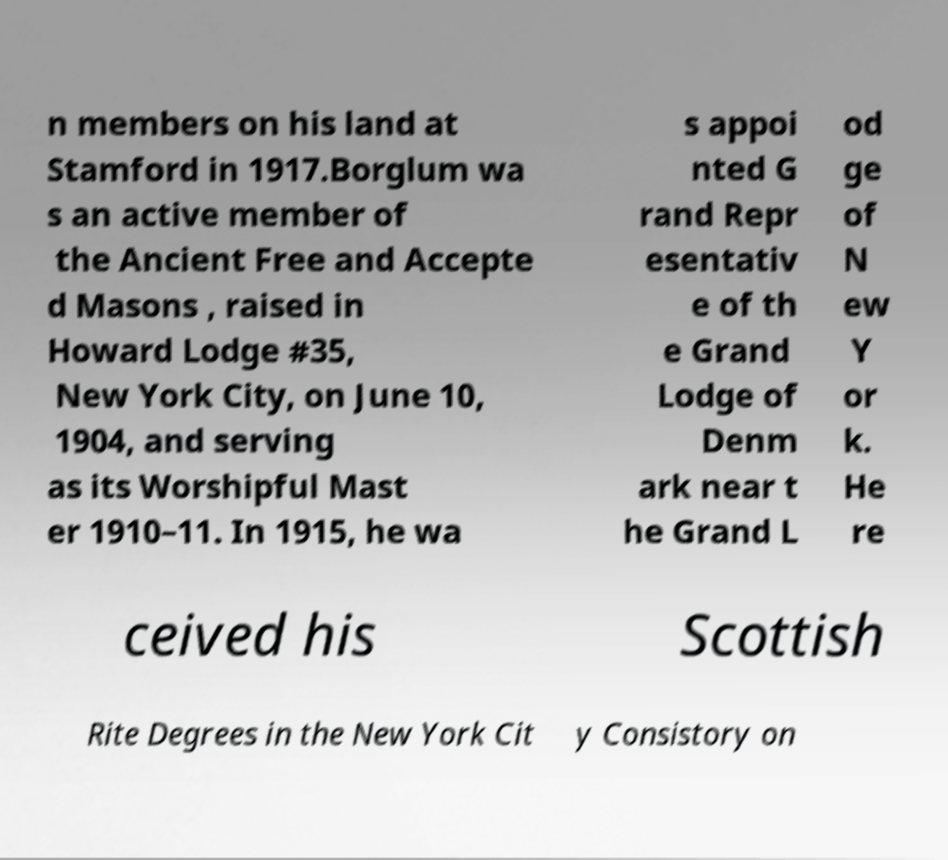For documentation purposes, I need the text within this image transcribed. Could you provide that? n members on his land at Stamford in 1917.Borglum wa s an active member of the Ancient Free and Accepte d Masons , raised in Howard Lodge #35, New York City, on June 10, 1904, and serving as its Worshipful Mast er 1910–11. In 1915, he wa s appoi nted G rand Repr esentativ e of th e Grand Lodge of Denm ark near t he Grand L od ge of N ew Y or k. He re ceived his Scottish Rite Degrees in the New York Cit y Consistory on 